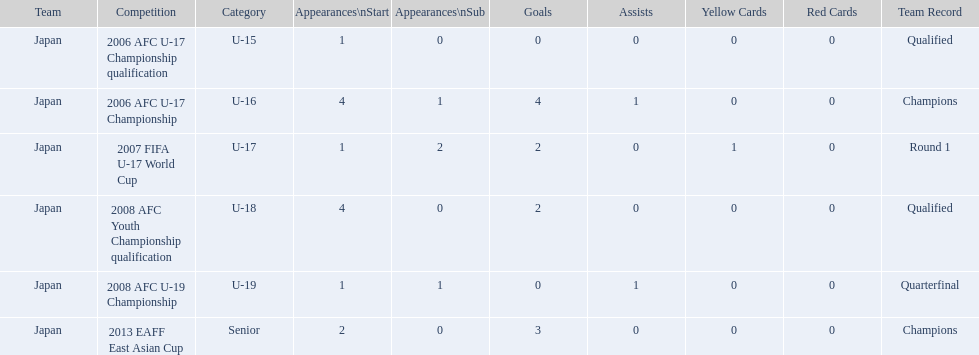Could you help me parse every detail presented in this table? {'header': ['Team', 'Competition', 'Category', 'Appearances\\nStart', 'Appearances\\nSub', 'Goals', 'Assists', 'Yellow Cards', 'Red Cards', 'Team Record'], 'rows': [['Japan', '2006 AFC U-17 Championship qualification', 'U-15', '1', '0', '0', '0', '0', '0', 'Qualified'], ['Japan', '2006 AFC U-17 Championship', 'U-16', '4', '1', '4', '1', '0', '0', 'Champions'], ['Japan', '2007 FIFA U-17 World Cup', 'U-17', '1', '2', '2', '0', '1', '0', 'Round 1'], ['Japan', '2008 AFC Youth Championship qualification', 'U-18', '4', '0', '2', '0', '0', '0', 'Qualified'], ['Japan', '2008 AFC U-19 Championship', 'U-19', '1', '1', '0', '1', '0', '0', 'Quarterfinal'], ['Japan', '2013 EAFF East Asian Cup', 'Senior', '2', '0', '3', '0', '0', '0', 'Champions']]} In how many significant tournaments did yoichiro kakitani score more than 2 goals? 2. 